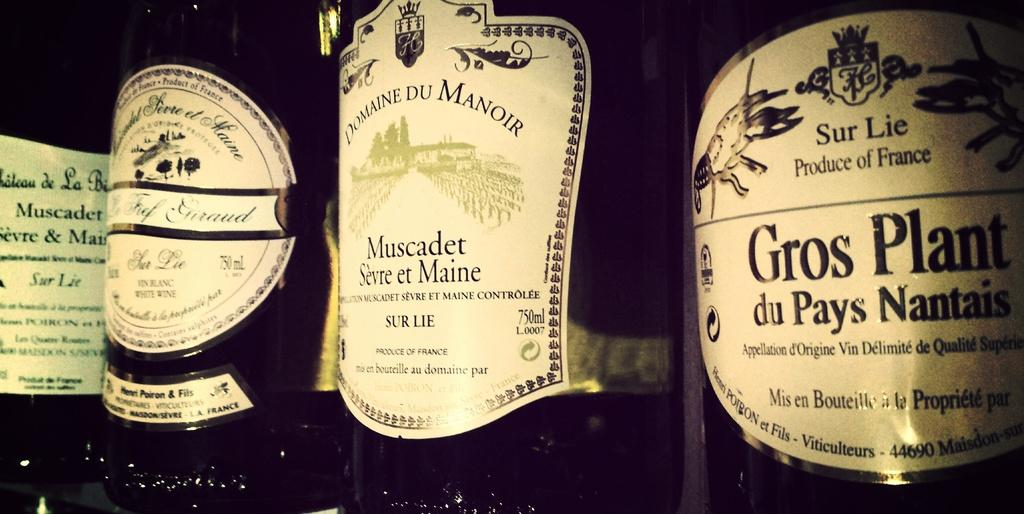<image>
Create a compact narrative representing the image presented. A bottle with the name Domaine Du Manoir on the label is between other bottles. 